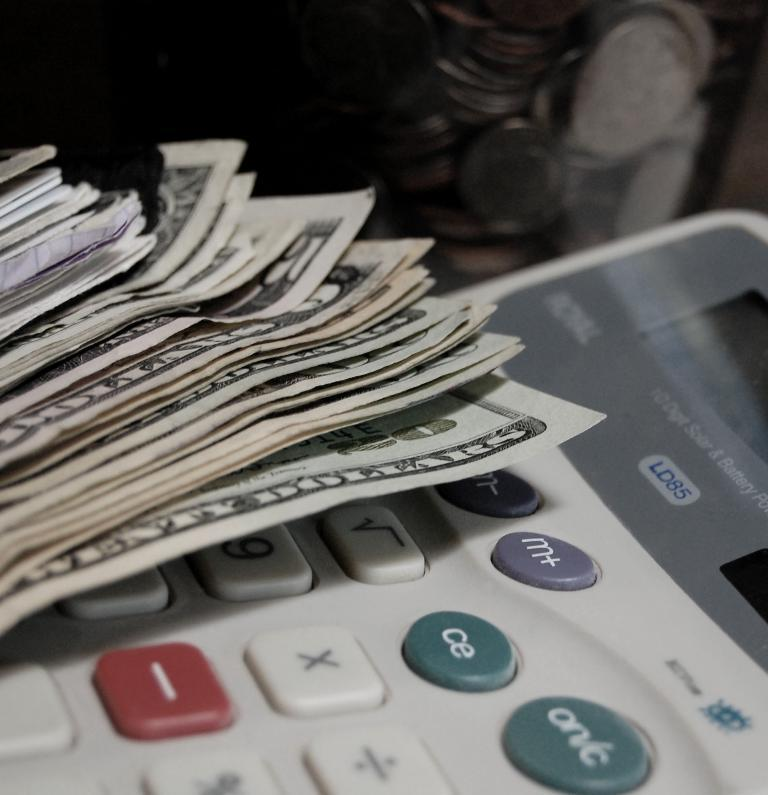<image>
Relay a brief, clear account of the picture shown. A stack of American twenty dollar and 5 dollar bills sits on top of an LD85 calculator 